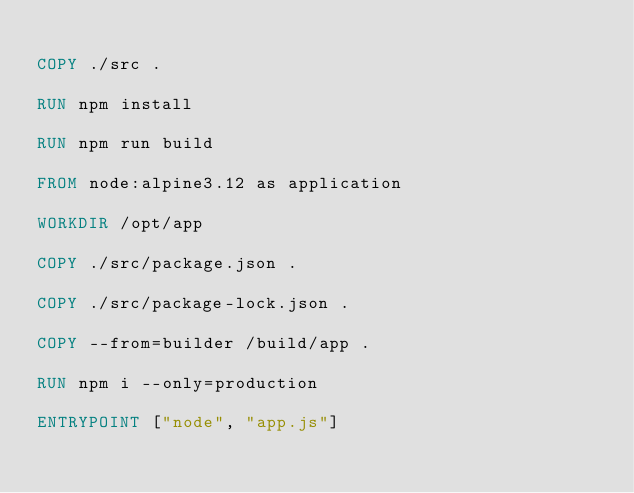Convert code to text. <code><loc_0><loc_0><loc_500><loc_500><_Dockerfile_>
COPY ./src .

RUN npm install

RUN npm run build

FROM node:alpine3.12 as application

WORKDIR /opt/app

COPY ./src/package.json .

COPY ./src/package-lock.json .

COPY --from=builder /build/app .

RUN npm i --only=production

ENTRYPOINT ["node", "app.js"]</code> 